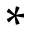<formula> <loc_0><loc_0><loc_500><loc_500>\ast</formula> 